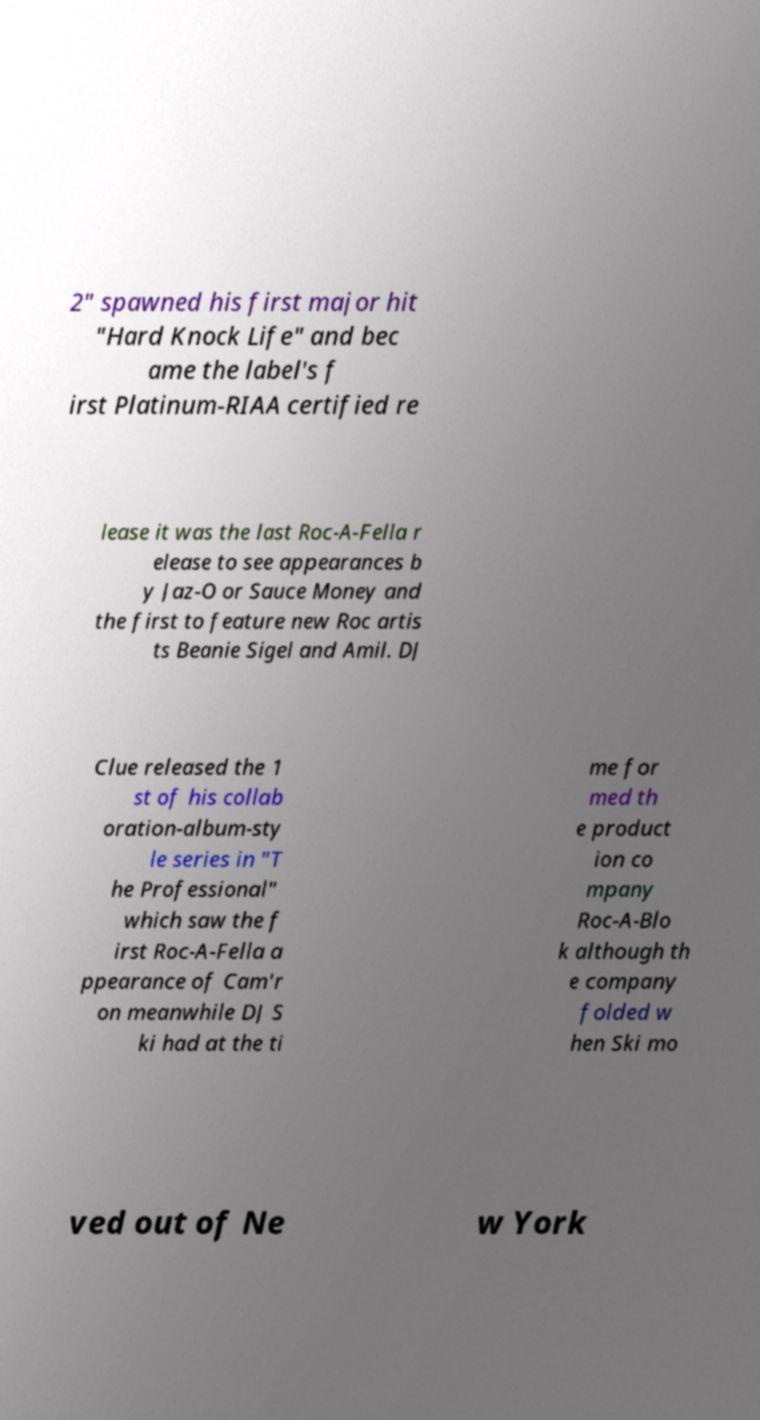Could you extract and type out the text from this image? 2" spawned his first major hit "Hard Knock Life" and bec ame the label's f irst Platinum-RIAA certified re lease it was the last Roc-A-Fella r elease to see appearances b y Jaz-O or Sauce Money and the first to feature new Roc artis ts Beanie Sigel and Amil. DJ Clue released the 1 st of his collab oration-album-sty le series in "T he Professional" which saw the f irst Roc-A-Fella a ppearance of Cam'r on meanwhile DJ S ki had at the ti me for med th e product ion co mpany Roc-A-Blo k although th e company folded w hen Ski mo ved out of Ne w York 